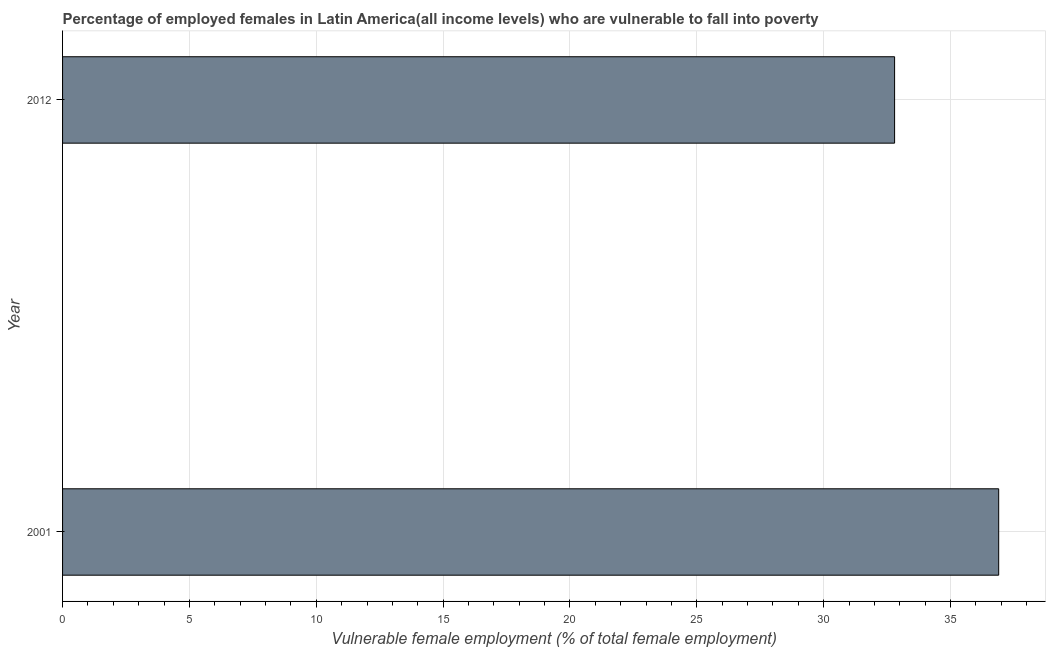Does the graph contain grids?
Keep it short and to the point. Yes. What is the title of the graph?
Offer a terse response. Percentage of employed females in Latin America(all income levels) who are vulnerable to fall into poverty. What is the label or title of the X-axis?
Your answer should be very brief. Vulnerable female employment (% of total female employment). What is the label or title of the Y-axis?
Offer a very short reply. Year. What is the percentage of employed females who are vulnerable to fall into poverty in 2001?
Give a very brief answer. 36.9. Across all years, what is the maximum percentage of employed females who are vulnerable to fall into poverty?
Provide a short and direct response. 36.9. Across all years, what is the minimum percentage of employed females who are vulnerable to fall into poverty?
Make the answer very short. 32.8. In which year was the percentage of employed females who are vulnerable to fall into poverty minimum?
Keep it short and to the point. 2012. What is the sum of the percentage of employed females who are vulnerable to fall into poverty?
Make the answer very short. 69.7. What is the difference between the percentage of employed females who are vulnerable to fall into poverty in 2001 and 2012?
Provide a succinct answer. 4.1. What is the average percentage of employed females who are vulnerable to fall into poverty per year?
Your answer should be very brief. 34.85. What is the median percentage of employed females who are vulnerable to fall into poverty?
Keep it short and to the point. 34.85. In how many years, is the percentage of employed females who are vulnerable to fall into poverty greater than 34 %?
Offer a very short reply. 1. What is the ratio of the percentage of employed females who are vulnerable to fall into poverty in 2001 to that in 2012?
Your response must be concise. 1.12. How many bars are there?
Provide a short and direct response. 2. What is the difference between two consecutive major ticks on the X-axis?
Keep it short and to the point. 5. What is the Vulnerable female employment (% of total female employment) of 2001?
Your answer should be very brief. 36.9. What is the Vulnerable female employment (% of total female employment) of 2012?
Offer a very short reply. 32.8. What is the difference between the Vulnerable female employment (% of total female employment) in 2001 and 2012?
Your response must be concise. 4.1. 